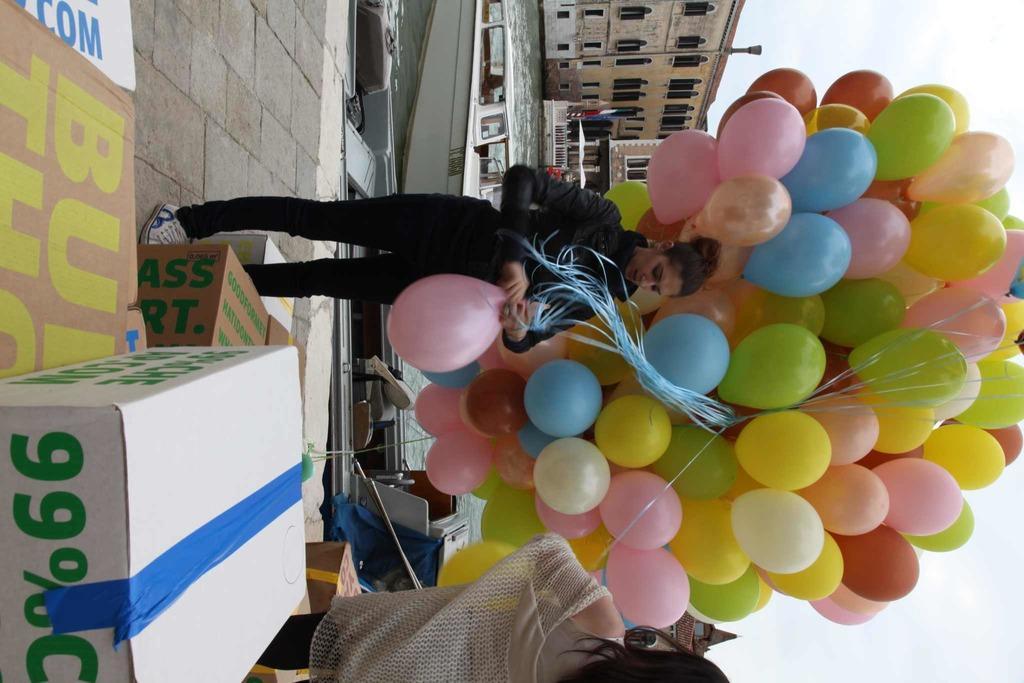Can you describe this image briefly? In this picture I can see there is a woman standing and holding a bunch of balloons in her hand. There are few carton boxes and a woman standing and in the backdrop there is a lake and a boat in the lake. There are few buildings and the sky is clear. 